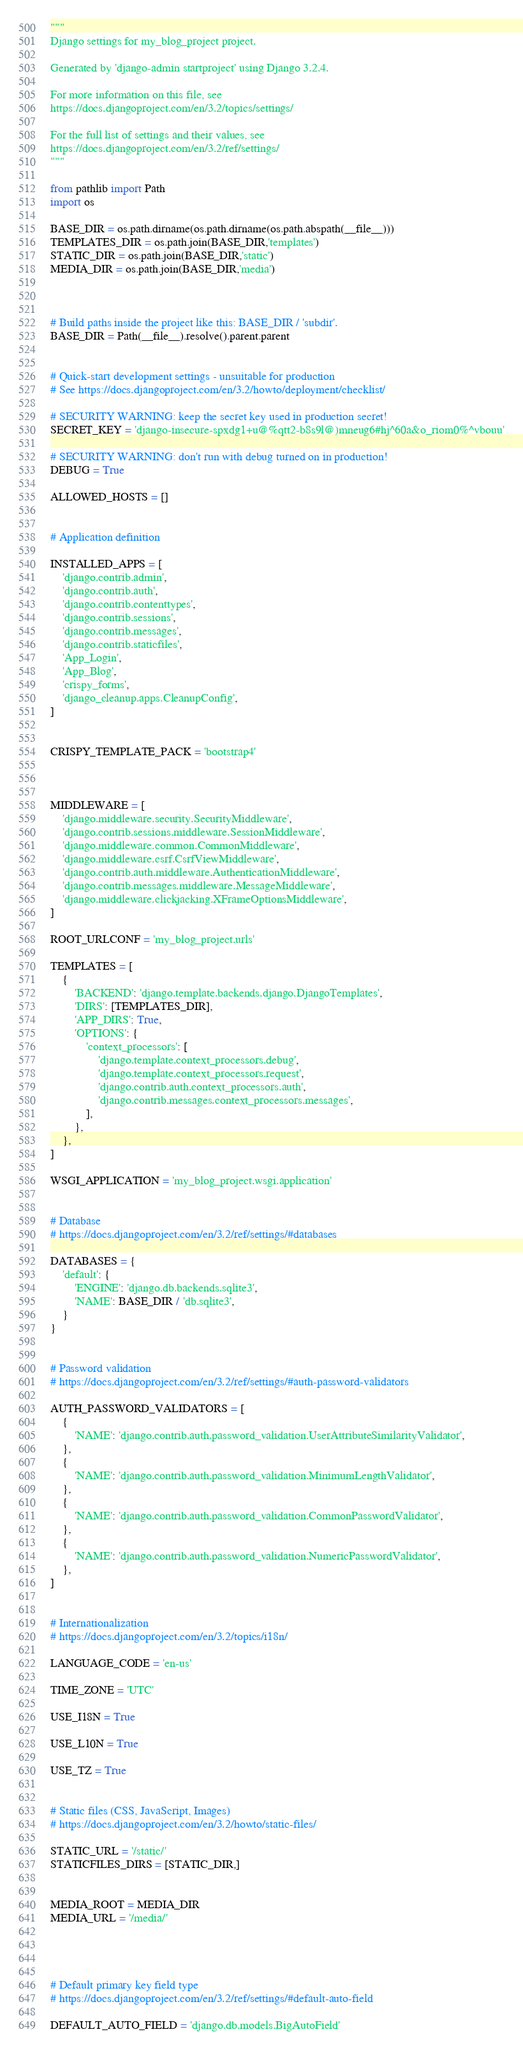Convert code to text. <code><loc_0><loc_0><loc_500><loc_500><_Python_>"""
Django settings for my_blog_project project.

Generated by 'django-admin startproject' using Django 3.2.4.

For more information on this file, see
https://docs.djangoproject.com/en/3.2/topics/settings/

For the full list of settings and their values, see
https://docs.djangoproject.com/en/3.2/ref/settings/
"""

from pathlib import Path
import os

BASE_DIR = os.path.dirname(os.path.dirname(os.path.abspath(__file__)))
TEMPLATES_DIR = os.path.join(BASE_DIR,'templates')
STATIC_DIR = os.path.join(BASE_DIR,'static')
MEDIA_DIR = os.path.join(BASE_DIR,'media')



# Build paths inside the project like this: BASE_DIR / 'subdir'.
BASE_DIR = Path(__file__).resolve().parent.parent


# Quick-start development settings - unsuitable for production
# See https://docs.djangoproject.com/en/3.2/howto/deployment/checklist/

# SECURITY WARNING: keep the secret key used in production secret!
SECRET_KEY = 'django-insecure-spxdg1+u@%qtt2-b8s9l@)mneug6#hj^60a&o_riom0%^vbouu'

# SECURITY WARNING: don't run with debug turned on in production!
DEBUG = True

ALLOWED_HOSTS = []


# Application definition

INSTALLED_APPS = [
    'django.contrib.admin',
    'django.contrib.auth',
    'django.contrib.contenttypes',
    'django.contrib.sessions',
    'django.contrib.messages',
    'django.contrib.staticfiles',
    'App_Login',
    'App_Blog',
    'crispy_forms',
    'django_cleanup.apps.CleanupConfig',
]


CRISPY_TEMPLATE_PACK = 'bootstrap4'



MIDDLEWARE = [
    'django.middleware.security.SecurityMiddleware',
    'django.contrib.sessions.middleware.SessionMiddleware',
    'django.middleware.common.CommonMiddleware',
    'django.middleware.csrf.CsrfViewMiddleware',
    'django.contrib.auth.middleware.AuthenticationMiddleware',
    'django.contrib.messages.middleware.MessageMiddleware',
    'django.middleware.clickjacking.XFrameOptionsMiddleware',
]

ROOT_URLCONF = 'my_blog_project.urls'

TEMPLATES = [
    {
        'BACKEND': 'django.template.backends.django.DjangoTemplates',
        'DIRS': [TEMPLATES_DIR],
        'APP_DIRS': True,
        'OPTIONS': {
            'context_processors': [
                'django.template.context_processors.debug',
                'django.template.context_processors.request',
                'django.contrib.auth.context_processors.auth',
                'django.contrib.messages.context_processors.messages',
            ],
        },
    },
]

WSGI_APPLICATION = 'my_blog_project.wsgi.application'


# Database
# https://docs.djangoproject.com/en/3.2/ref/settings/#databases

DATABASES = {
    'default': {
        'ENGINE': 'django.db.backends.sqlite3',
        'NAME': BASE_DIR / 'db.sqlite3',
    }
}


# Password validation
# https://docs.djangoproject.com/en/3.2/ref/settings/#auth-password-validators

AUTH_PASSWORD_VALIDATORS = [
    {
        'NAME': 'django.contrib.auth.password_validation.UserAttributeSimilarityValidator',
    },
    {
        'NAME': 'django.contrib.auth.password_validation.MinimumLengthValidator',
    },
    {
        'NAME': 'django.contrib.auth.password_validation.CommonPasswordValidator',
    },
    {
        'NAME': 'django.contrib.auth.password_validation.NumericPasswordValidator',
    },
]


# Internationalization
# https://docs.djangoproject.com/en/3.2/topics/i18n/

LANGUAGE_CODE = 'en-us'

TIME_ZONE = 'UTC'

USE_I18N = True

USE_L10N = True

USE_TZ = True


# Static files (CSS, JavaScript, Images)
# https://docs.djangoproject.com/en/3.2/howto/static-files/

STATIC_URL = '/static/'
STATICFILES_DIRS = [STATIC_DIR,]


MEDIA_ROOT = MEDIA_DIR
MEDIA_URL = '/media/'




# Default primary key field type
# https://docs.djangoproject.com/en/3.2/ref/settings/#default-auto-field

DEFAULT_AUTO_FIELD = 'django.db.models.BigAutoField'
</code> 